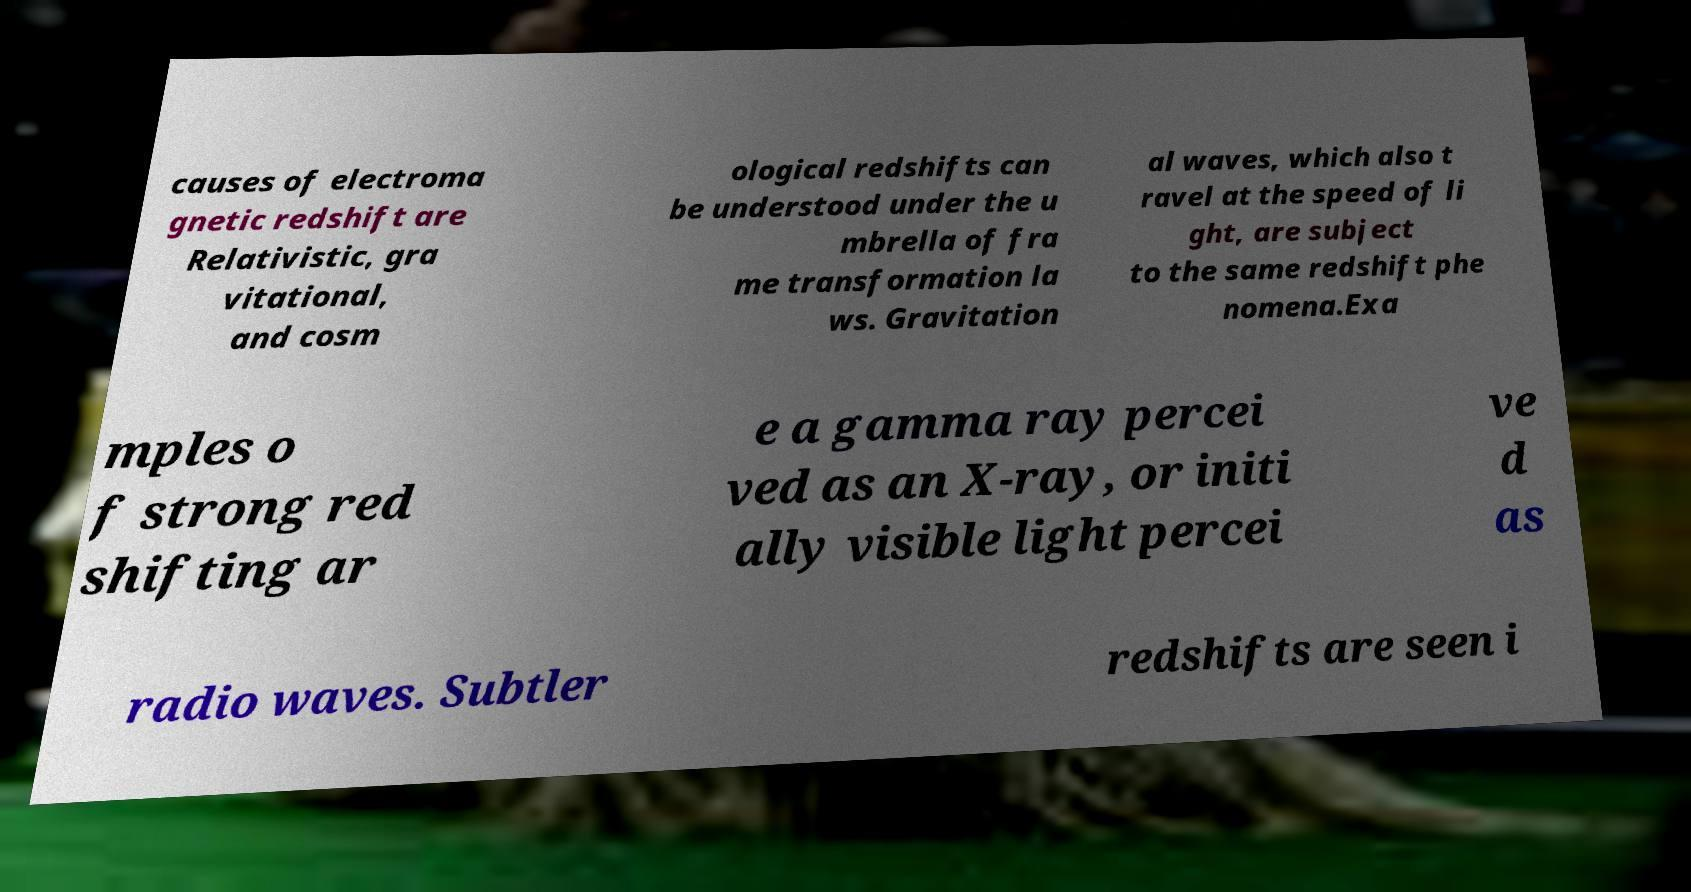Please read and relay the text visible in this image. What does it say? causes of electroma gnetic redshift are Relativistic, gra vitational, and cosm ological redshifts can be understood under the u mbrella of fra me transformation la ws. Gravitation al waves, which also t ravel at the speed of li ght, are subject to the same redshift phe nomena.Exa mples o f strong red shifting ar e a gamma ray percei ved as an X-ray, or initi ally visible light percei ve d as radio waves. Subtler redshifts are seen i 